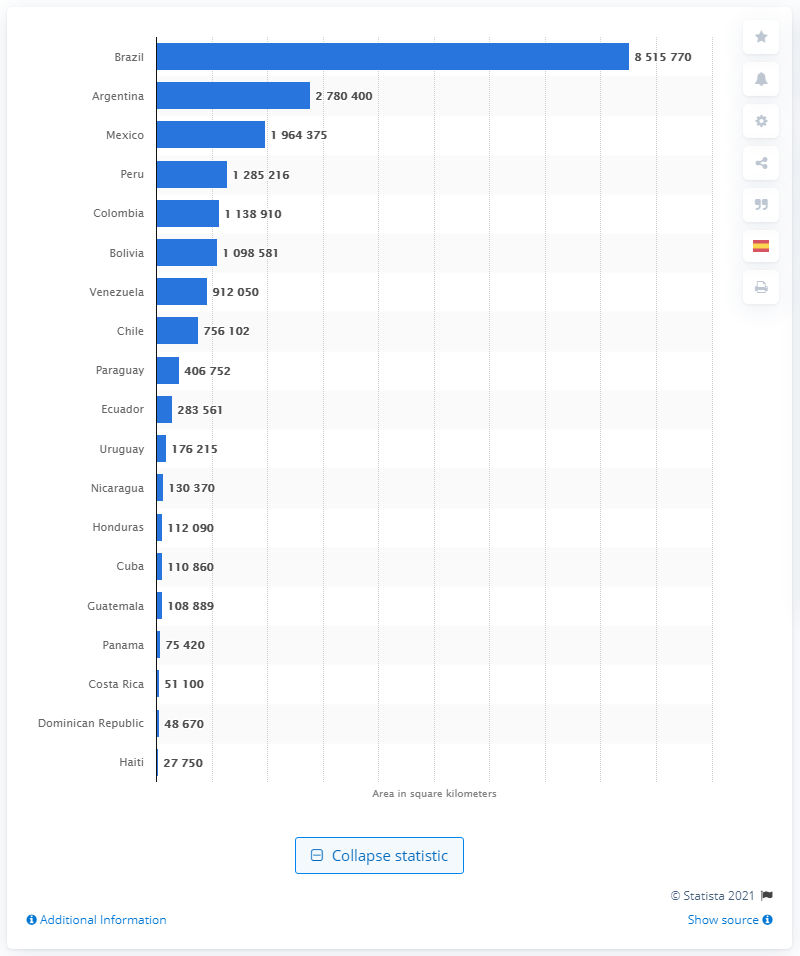What is the largest country in Latin America?
 Brazil 